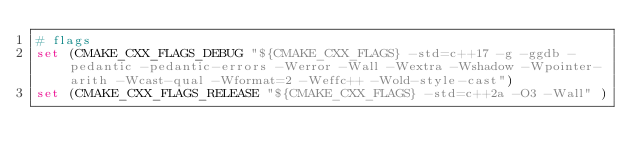Convert code to text. <code><loc_0><loc_0><loc_500><loc_500><_CMake_># flags
set (CMAKE_CXX_FLAGS_DEBUG "${CMAKE_CXX_FLAGS} -std=c++17 -g -ggdb -pedantic -pedantic-errors -Werror -Wall -Wextra -Wshadow -Wpointer-arith -Wcast-qual -Wformat=2 -Weffc++ -Wold-style-cast")
set (CMAKE_CXX_FLAGS_RELEASE "${CMAKE_CXX_FLAGS} -std=c++2a -O3 -Wall" ) </code> 